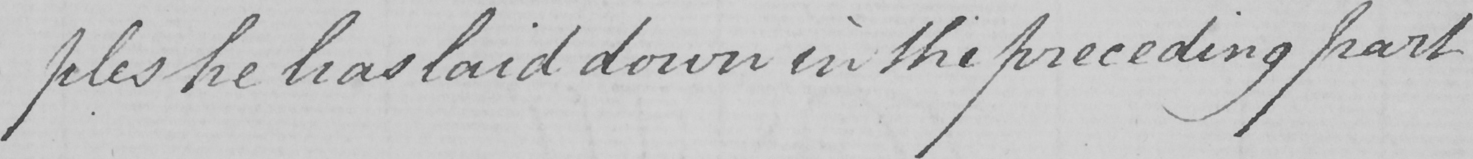Can you tell me what this handwritten text says? -ples he has laid down in the preceding part 